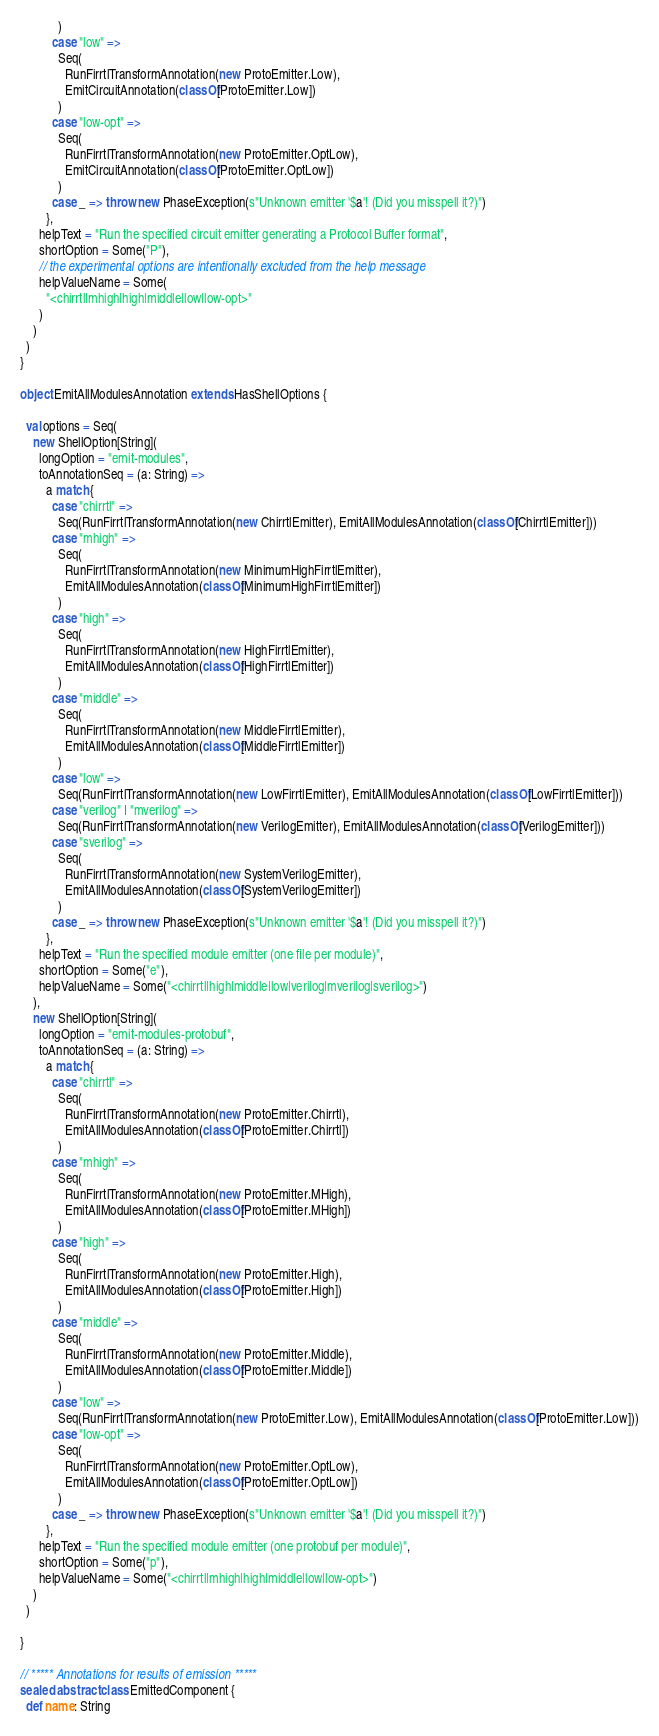<code> <loc_0><loc_0><loc_500><loc_500><_Scala_>            )
          case "low" =>
            Seq(
              RunFirrtlTransformAnnotation(new ProtoEmitter.Low),
              EmitCircuitAnnotation(classOf[ProtoEmitter.Low])
            )
          case "low-opt" =>
            Seq(
              RunFirrtlTransformAnnotation(new ProtoEmitter.OptLow),
              EmitCircuitAnnotation(classOf[ProtoEmitter.OptLow])
            )
          case _ => throw new PhaseException(s"Unknown emitter '$a'! (Did you misspell it?)")
        },
      helpText = "Run the specified circuit emitter generating a Protocol Buffer format",
      shortOption = Some("P"),
      // the experimental options are intentionally excluded from the help message
      helpValueName = Some(
        "<chirrtl|mhigh|high|middle|low|low-opt>"
      )
    )
  )
}

object EmitAllModulesAnnotation extends HasShellOptions {

  val options = Seq(
    new ShellOption[String](
      longOption = "emit-modules",
      toAnnotationSeq = (a: String) =>
        a match {
          case "chirrtl" =>
            Seq(RunFirrtlTransformAnnotation(new ChirrtlEmitter), EmitAllModulesAnnotation(classOf[ChirrtlEmitter]))
          case "mhigh" =>
            Seq(
              RunFirrtlTransformAnnotation(new MinimumHighFirrtlEmitter),
              EmitAllModulesAnnotation(classOf[MinimumHighFirrtlEmitter])
            )
          case "high" =>
            Seq(
              RunFirrtlTransformAnnotation(new HighFirrtlEmitter),
              EmitAllModulesAnnotation(classOf[HighFirrtlEmitter])
            )
          case "middle" =>
            Seq(
              RunFirrtlTransformAnnotation(new MiddleFirrtlEmitter),
              EmitAllModulesAnnotation(classOf[MiddleFirrtlEmitter])
            )
          case "low" =>
            Seq(RunFirrtlTransformAnnotation(new LowFirrtlEmitter), EmitAllModulesAnnotation(classOf[LowFirrtlEmitter]))
          case "verilog" | "mverilog" =>
            Seq(RunFirrtlTransformAnnotation(new VerilogEmitter), EmitAllModulesAnnotation(classOf[VerilogEmitter]))
          case "sverilog" =>
            Seq(
              RunFirrtlTransformAnnotation(new SystemVerilogEmitter),
              EmitAllModulesAnnotation(classOf[SystemVerilogEmitter])
            )
          case _ => throw new PhaseException(s"Unknown emitter '$a'! (Did you misspell it?)")
        },
      helpText = "Run the specified module emitter (one file per module)",
      shortOption = Some("e"),
      helpValueName = Some("<chirrtl|high|middle|low|verilog|mverilog|sverilog>")
    ),
    new ShellOption[String](
      longOption = "emit-modules-protobuf",
      toAnnotationSeq = (a: String) =>
        a match {
          case "chirrtl" =>
            Seq(
              RunFirrtlTransformAnnotation(new ProtoEmitter.Chirrtl),
              EmitAllModulesAnnotation(classOf[ProtoEmitter.Chirrtl])
            )
          case "mhigh" =>
            Seq(
              RunFirrtlTransformAnnotation(new ProtoEmitter.MHigh),
              EmitAllModulesAnnotation(classOf[ProtoEmitter.MHigh])
            )
          case "high" =>
            Seq(
              RunFirrtlTransformAnnotation(new ProtoEmitter.High),
              EmitAllModulesAnnotation(classOf[ProtoEmitter.High])
            )
          case "middle" =>
            Seq(
              RunFirrtlTransformAnnotation(new ProtoEmitter.Middle),
              EmitAllModulesAnnotation(classOf[ProtoEmitter.Middle])
            )
          case "low" =>
            Seq(RunFirrtlTransformAnnotation(new ProtoEmitter.Low), EmitAllModulesAnnotation(classOf[ProtoEmitter.Low]))
          case "low-opt" =>
            Seq(
              RunFirrtlTransformAnnotation(new ProtoEmitter.OptLow),
              EmitAllModulesAnnotation(classOf[ProtoEmitter.OptLow])
            )
          case _ => throw new PhaseException(s"Unknown emitter '$a'! (Did you misspell it?)")
        },
      helpText = "Run the specified module emitter (one protobuf per module)",
      shortOption = Some("p"),
      helpValueName = Some("<chirrtl|mhigh|high|middle|low|low-opt>")
    )
  )

}

// ***** Annotations for results of emission *****
sealed abstract class EmittedComponent {
  def name: String
</code> 